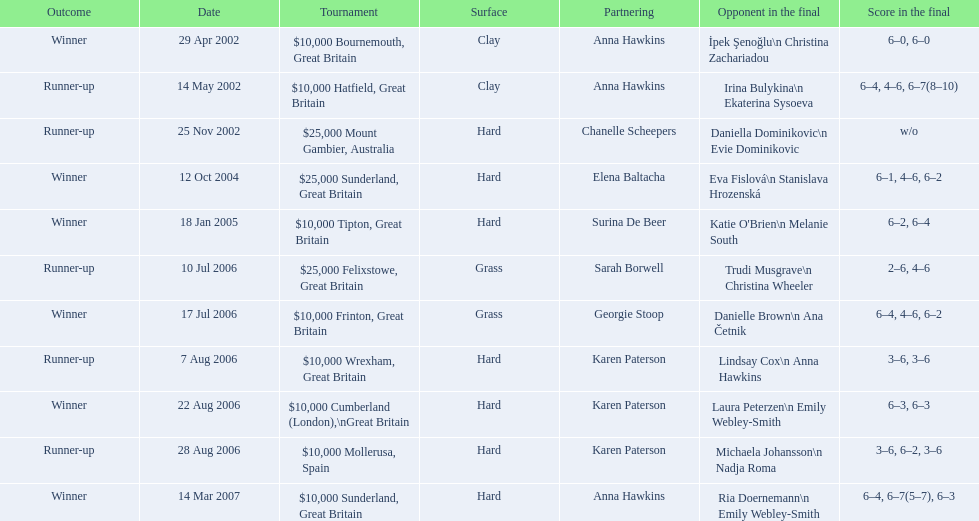What is the partnering name above chanelle scheepers? Anna Hawkins. 